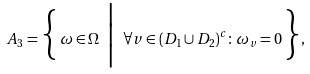<formula> <loc_0><loc_0><loc_500><loc_500>A _ { 3 } = \Big \{ \, \omega \in \Omega \ \Big | \ \forall { v \in ( D _ { 1 } \cup D _ { 2 } ) ^ { c } } \colon \omega _ { v } = 0 \, \Big \} ,</formula> 